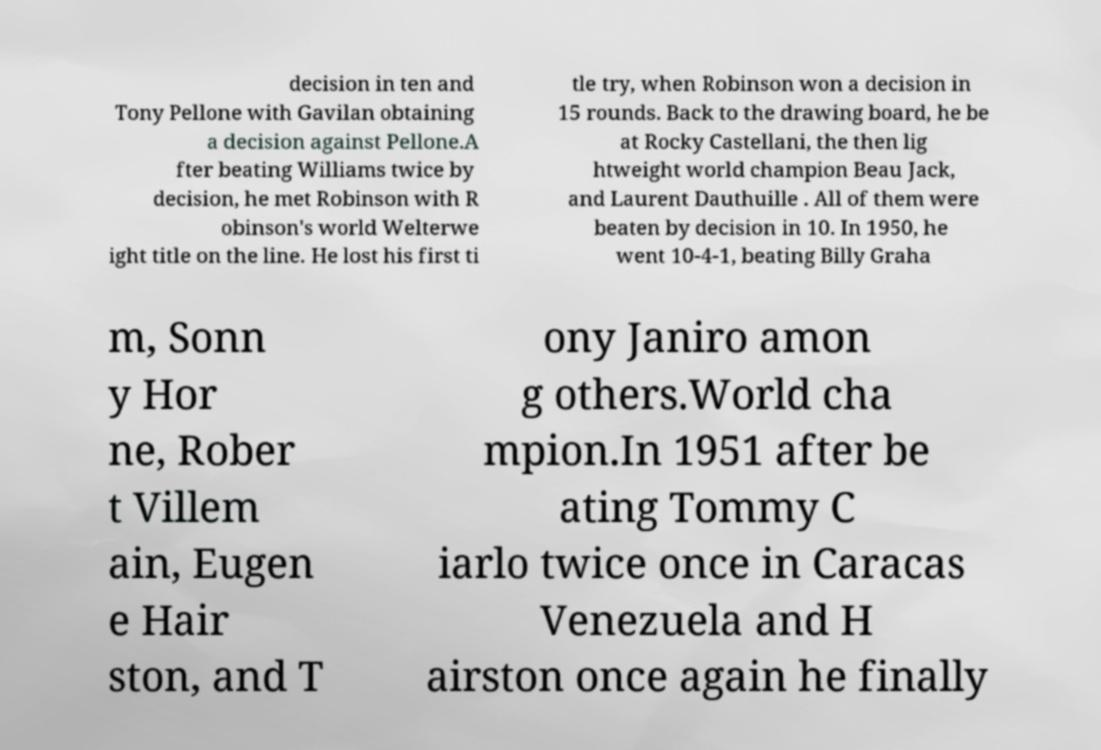There's text embedded in this image that I need extracted. Can you transcribe it verbatim? decision in ten and Tony Pellone with Gavilan obtaining a decision against Pellone.A fter beating Williams twice by decision, he met Robinson with R obinson's world Welterwe ight title on the line. He lost his first ti tle try, when Robinson won a decision in 15 rounds. Back to the drawing board, he be at Rocky Castellani, the then lig htweight world champion Beau Jack, and Laurent Dauthuille . All of them were beaten by decision in 10. In 1950, he went 10-4-1, beating Billy Graha m, Sonn y Hor ne, Rober t Villem ain, Eugen e Hair ston, and T ony Janiro amon g others.World cha mpion.In 1951 after be ating Tommy C iarlo twice once in Caracas Venezuela and H airston once again he finally 